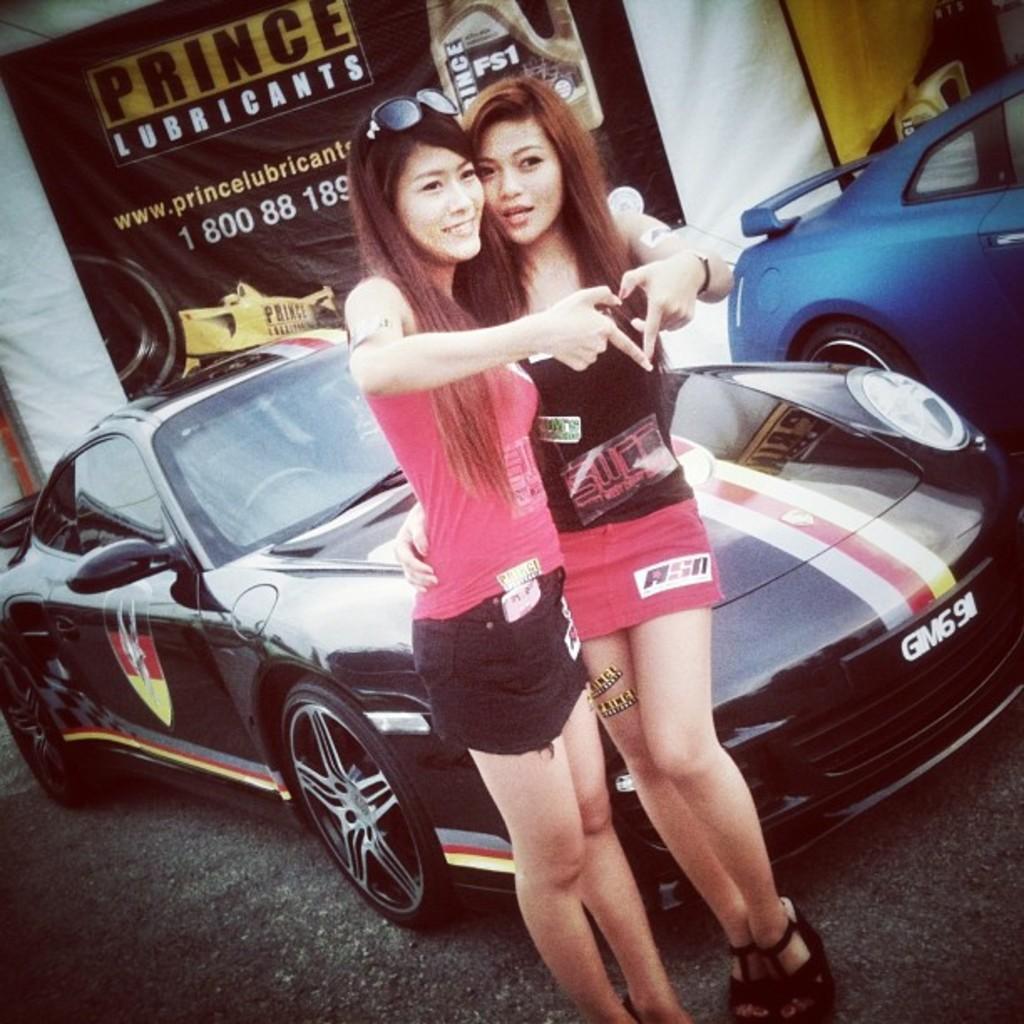Please provide a concise description of this image. In this image I can see two persons standing, the person at left wearing pink shirt, black short and the person at right wearing black shirt, pink short. Background I can see few vehicles, in front the vehicle is in black color and I can see a black color banner. 